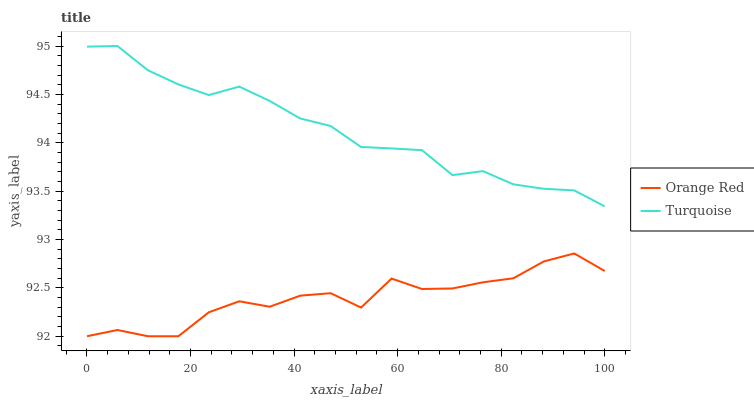Does Orange Red have the minimum area under the curve?
Answer yes or no. Yes. Does Turquoise have the maximum area under the curve?
Answer yes or no. Yes. Does Orange Red have the maximum area under the curve?
Answer yes or no. No. Is Turquoise the smoothest?
Answer yes or no. Yes. Is Orange Red the roughest?
Answer yes or no. Yes. Is Orange Red the smoothest?
Answer yes or no. No. Does Orange Red have the lowest value?
Answer yes or no. Yes. Does Turquoise have the highest value?
Answer yes or no. Yes. Does Orange Red have the highest value?
Answer yes or no. No. Is Orange Red less than Turquoise?
Answer yes or no. Yes. Is Turquoise greater than Orange Red?
Answer yes or no. Yes. Does Orange Red intersect Turquoise?
Answer yes or no. No. 